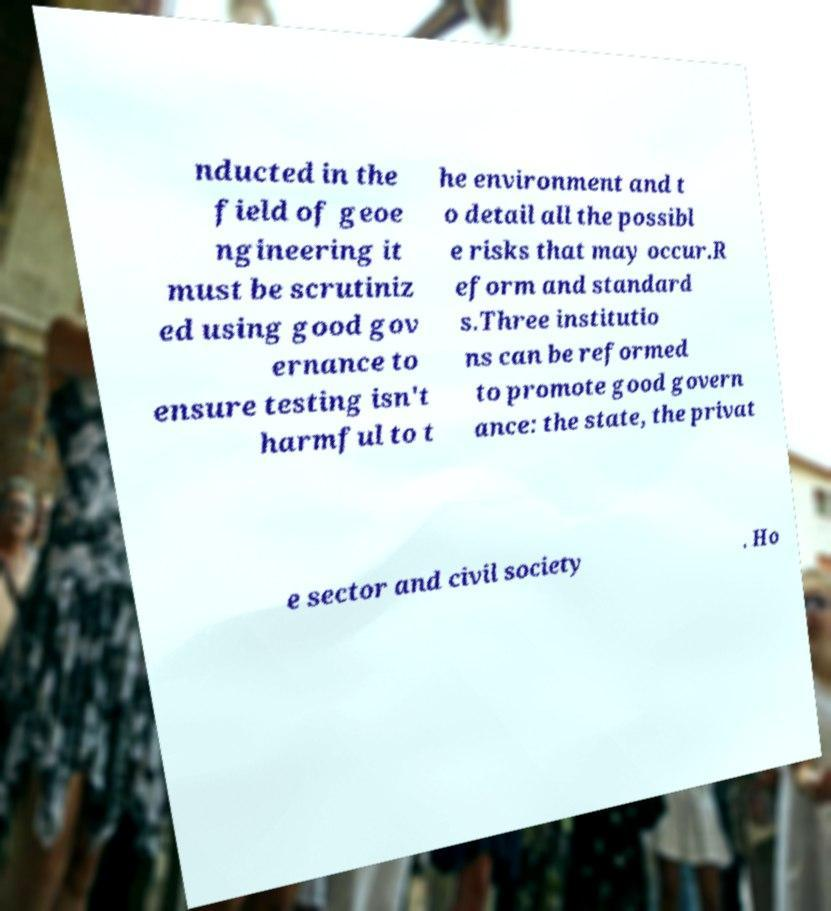I need the written content from this picture converted into text. Can you do that? nducted in the field of geoe ngineering it must be scrutiniz ed using good gov ernance to ensure testing isn't harmful to t he environment and t o detail all the possibl e risks that may occur.R eform and standard s.Three institutio ns can be reformed to promote good govern ance: the state, the privat e sector and civil society . Ho 